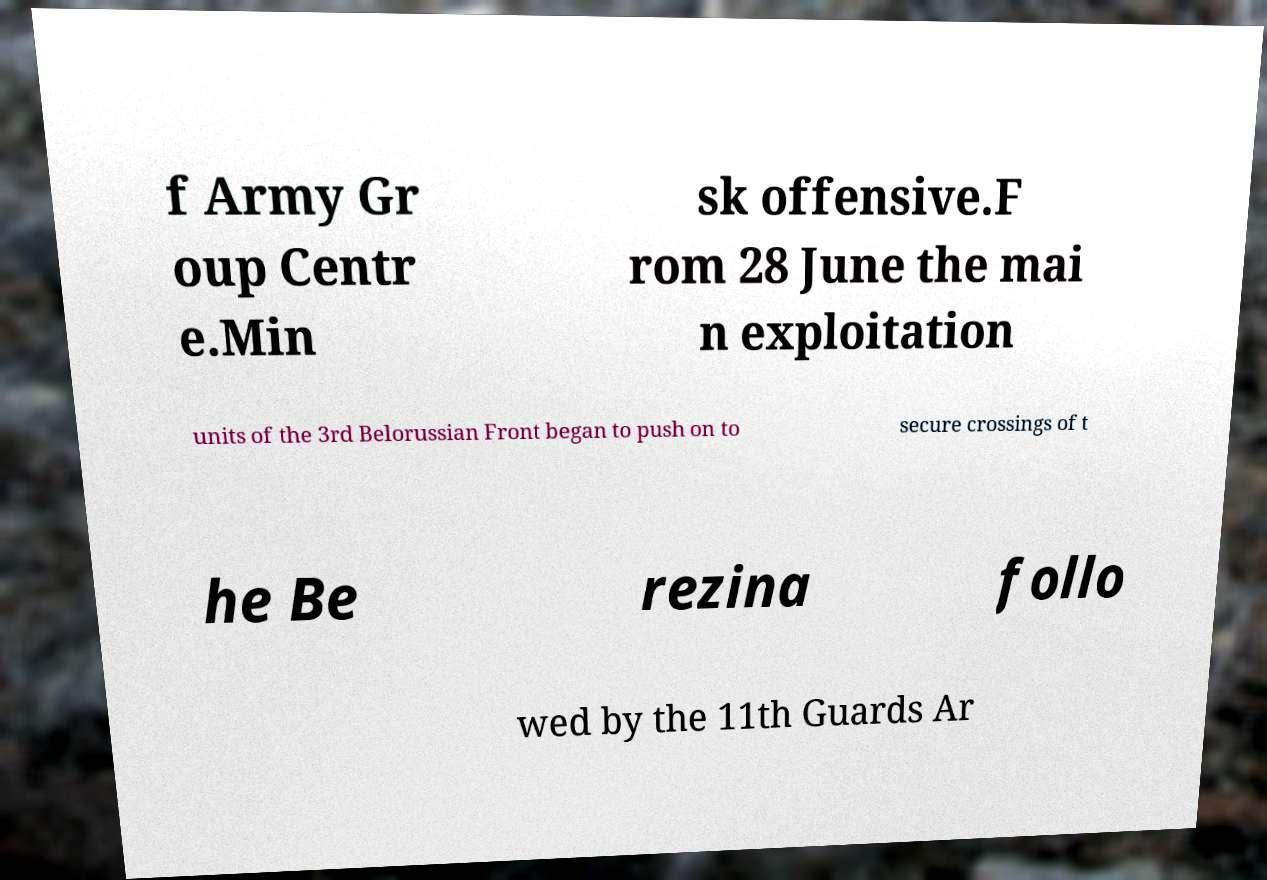Could you extract and type out the text from this image? f Army Gr oup Centr e.Min sk offensive.F rom 28 June the mai n exploitation units of the 3rd Belorussian Front began to push on to secure crossings of t he Be rezina follo wed by the 11th Guards Ar 